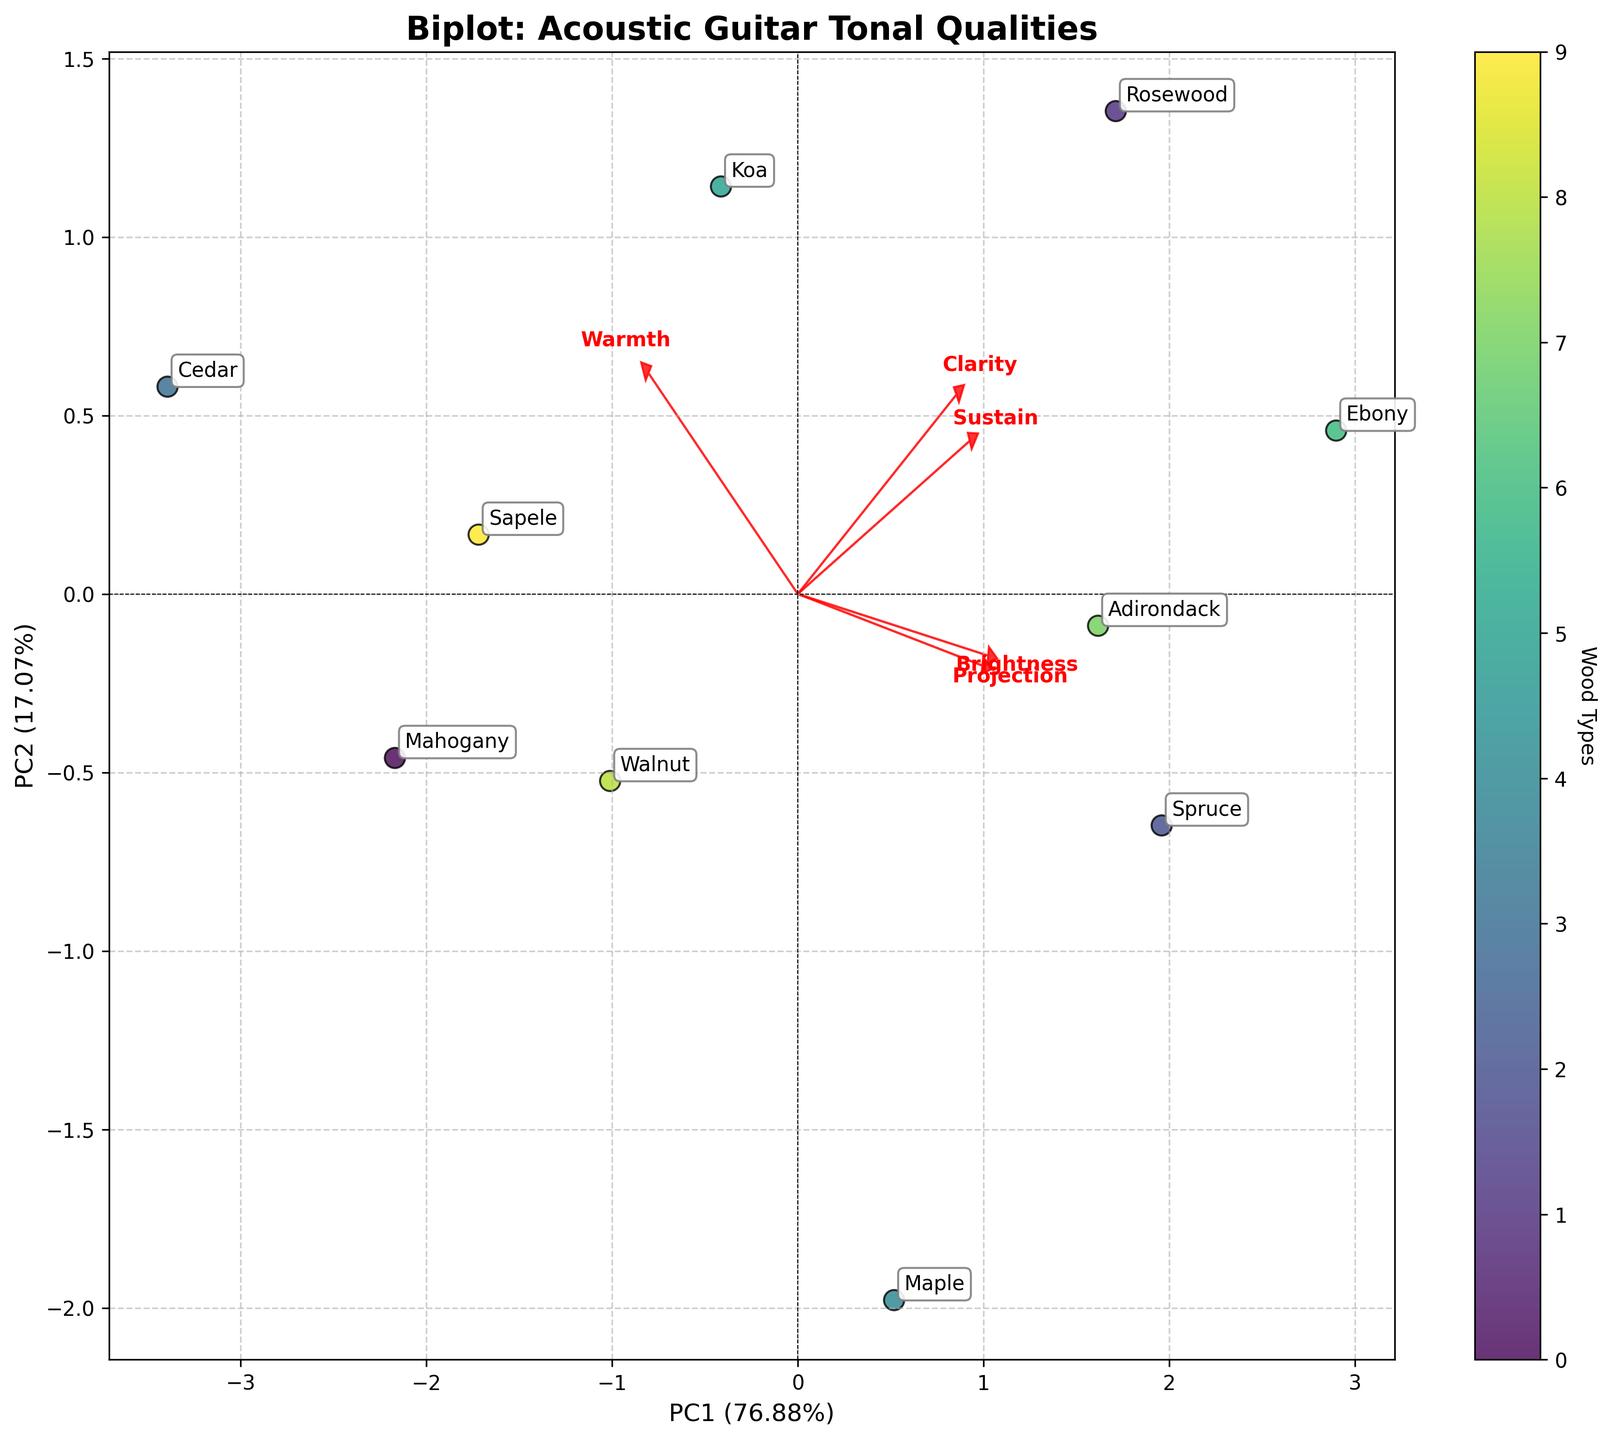Which wood type appears to have the highest projection? By looking at the biplot, find the data point that is furthest along the 'Projection' arrow. Both 'Ebony' and 'Spruce' are positioned close to the projection vector, indicating high projection.
Answer: Ebony, Spruce Which wood type shows the greatest warmth? Check which data point is positioned furthest along the 'Warmth' arrow. Cedar is the most aligned with the 'Warmth' vector, indicating it has the greatest warmth.
Answer: Cedar What is the title of the figure? The title is clearly indicated at the top of the plot.
Answer: Biplot: Acoustic Guitar Tonal Qualities How many wood types are compared in the biplot? Count the number of unique labels on the plot, which correspond to each wood type. There are 10 labels present.
Answer: 10 Which two wood types have similar properties in terms of warmth and projection? Look for data points positioned close to each other in the directions of 'Warmth' and 'Projection'. Mahogany and Sapele are close together in these dimensions, indicating similar properties.
Answer: Mahogany and Sapele By what percentage does PC1 explain the variance in the data? Read off the percentage value from the x-axis label, which indicates the explained variance for PC1.
Answer: 30.20% Which wood type is most associated with high clarity? Check the data point that lies furthest in the direction of 'Clarity'. Ebony is closest to this vector.
Answer: Ebony Do 'Maple' and 'Koa' have distinct tonal qualities? Compare their positions in the biplot. Maple and Koa are positioned closely, indicating they share similar tonal qualities.
Answer: No, they are similar Which two tonal qualities have the highest loadings on PC2? Look at the direction and length of the arrows corresponding to features. The vectors for 'Brightness' and 'Clarity' point strongly in the direction of PC2.
Answer: Brightness and Clarity Which wood type has the most balanced tonal qualities? Find the data point closest to the origin (0,0), which suggests balanced attributes. Walnut appears closest to the center, indicating balanced qualities.
Answer: Walnut 